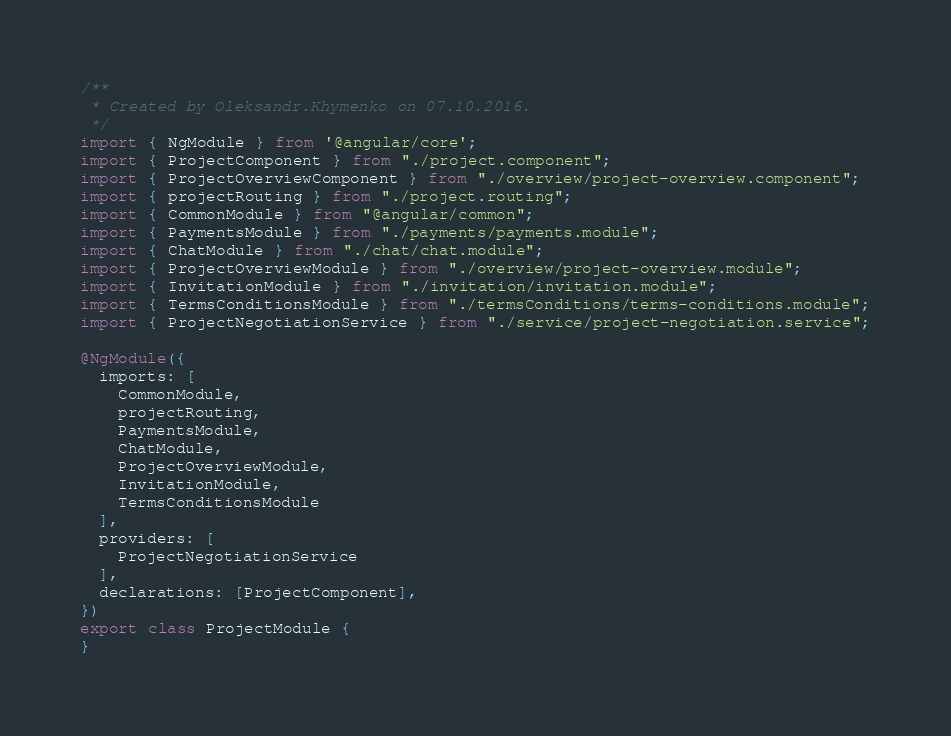<code> <loc_0><loc_0><loc_500><loc_500><_TypeScript_>/**
 * Created by Oleksandr.Khymenko on 07.10.2016.
 */
import { NgModule } from '@angular/core';
import { ProjectComponent } from "./project.component";
import { ProjectOverviewComponent } from "./overview/project-overview.component";
import { projectRouting } from "./project.routing";
import { CommonModule } from "@angular/common";
import { PaymentsModule } from "./payments/payments.module";
import { ChatModule } from "./chat/chat.module";
import { ProjectOverviewModule } from "./overview/project-overview.module";
import { InvitationModule } from "./invitation/invitation.module";
import { TermsConditionsModule } from "./termsConditions/terms-conditions.module";
import { ProjectNegotiationService } from "./service/project-negotiation.service";

@NgModule({
  imports: [
    CommonModule,
    projectRouting,
    PaymentsModule,
    ChatModule,
    ProjectOverviewModule,
    InvitationModule,
    TermsConditionsModule
  ],
  providers: [
    ProjectNegotiationService
  ],
  declarations: [ProjectComponent],
})
export class ProjectModule {
}
</code> 